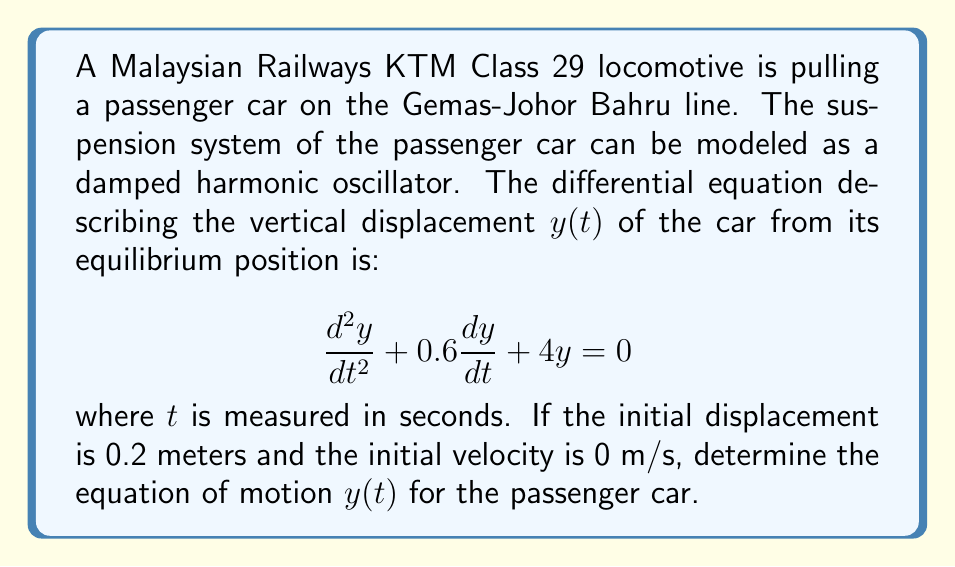Solve this math problem. To solve this problem, we need to follow these steps:

1) First, we identify that this is a second-order linear homogeneous differential equation with constant coefficients. The general form is:

   $$\frac{d^2y}{dt^2} + 2\zeta\omega_n\frac{dy}{dt} + \omega_n^2y = 0$$

   where $\zeta$ is the damping ratio and $\omega_n$ is the natural frequency.

2) Comparing our equation to the general form, we can see that:
   
   $2\zeta\omega_n = 0.6$ and $\omega_n^2 = 4$

3) We can calculate $\omega_n = \sqrt{4} = 2$ rad/s

4) Then, $\zeta = \frac{0.6}{2\omega_n} = \frac{0.6}{4} = 0.15$

5) Since $0 < \zeta < 1$, this is an underdamped system. The general solution for an underdamped system is:

   $$y(t) = e^{-\zeta\omega_nt}(A\cos(\omega_dt) + B\sin(\omega_dt))$$

   where $\omega_d = \omega_n\sqrt{1-\zeta^2}$ is the damped natural frequency.

6) Calculate $\omega_d$:
   
   $$\omega_d = 2\sqrt{1-0.15^2} \approx 1.96 \text{ rad/s}$$

7) Now we need to use the initial conditions to find A and B:
   
   At $t=0$, $y(0) = 0.2$ and $y'(0) = 0$

8) From $y(0) = 0.2$:
   
   $$0.2 = A$$

9) From $y'(0) = 0$:
   
   $$0 = -0.3A + 1.96B$$
   $$B = \frac{0.3A}{1.96} \approx 0.0306$$

10) Therefore, the equation of motion is:

    $$y(t) = e^{-0.3t}(0.2\cos(1.96t) + 0.0306\sin(1.96t))$$
Answer: $y(t) = e^{-0.3t}(0.2\cos(1.96t) + 0.0306\sin(1.96t))$ 